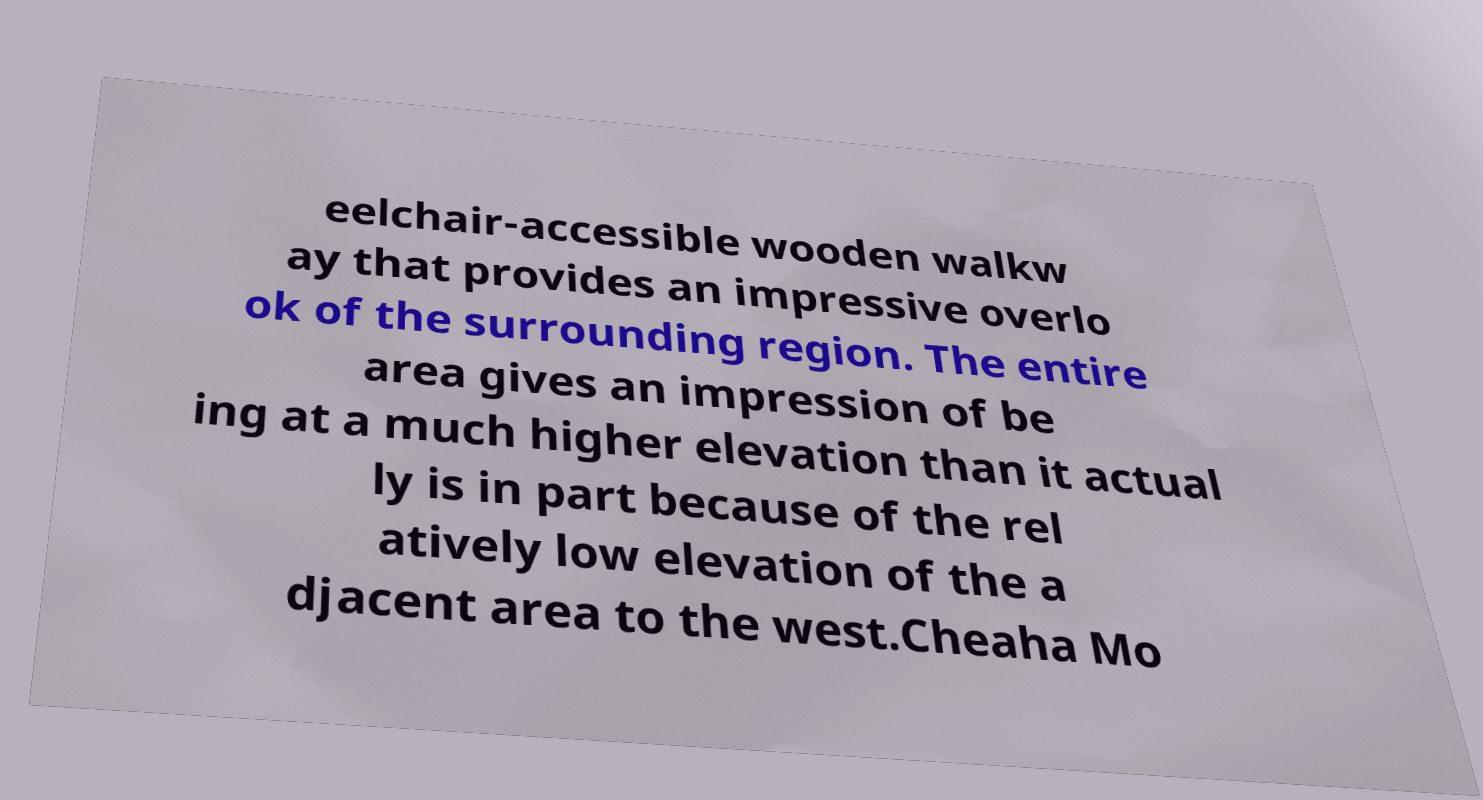For documentation purposes, I need the text within this image transcribed. Could you provide that? eelchair-accessible wooden walkw ay that provides an impressive overlo ok of the surrounding region. The entire area gives an impression of be ing at a much higher elevation than it actual ly is in part because of the rel atively low elevation of the a djacent area to the west.Cheaha Mo 